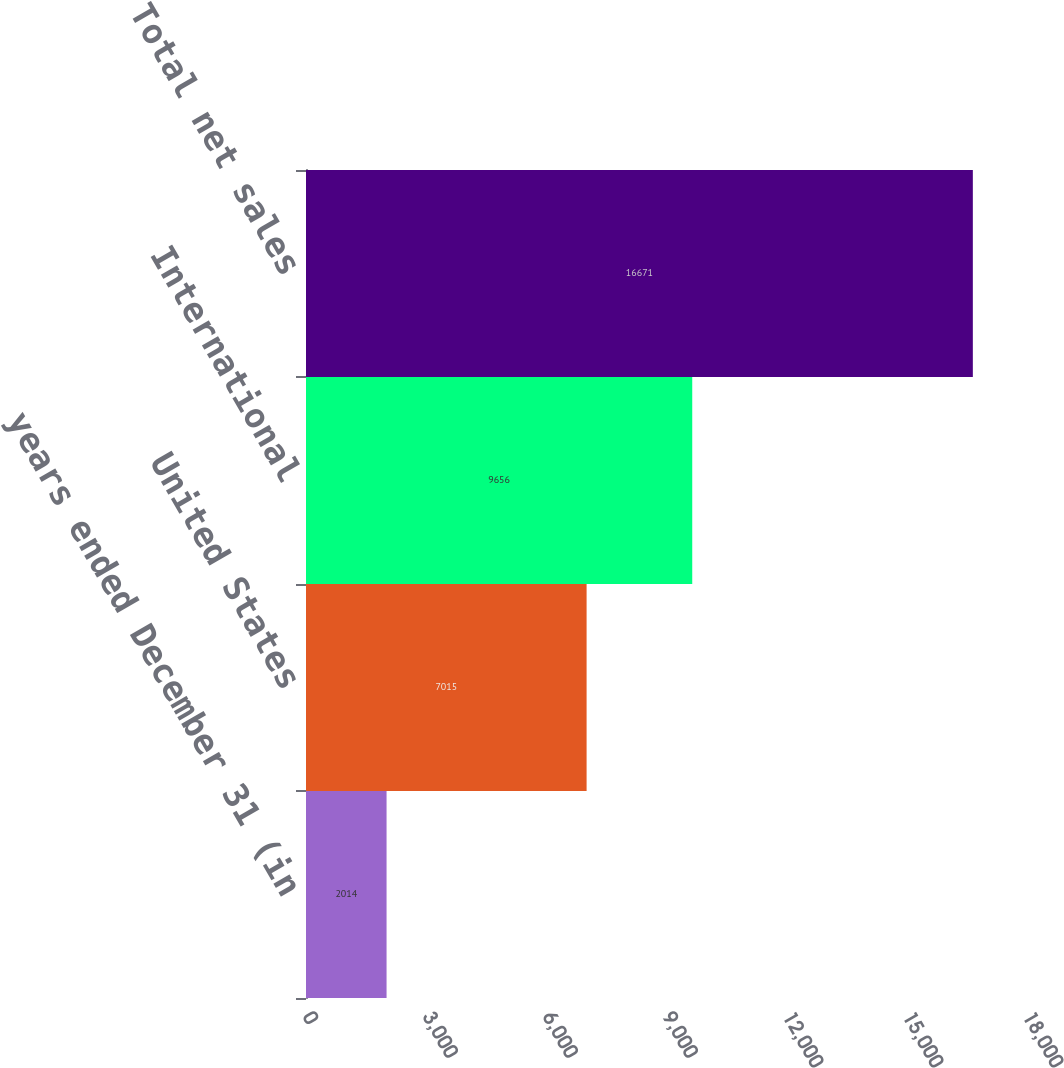Convert chart. <chart><loc_0><loc_0><loc_500><loc_500><bar_chart><fcel>years ended December 31 (in<fcel>United States<fcel>International<fcel>Total net sales<nl><fcel>2014<fcel>7015<fcel>9656<fcel>16671<nl></chart> 